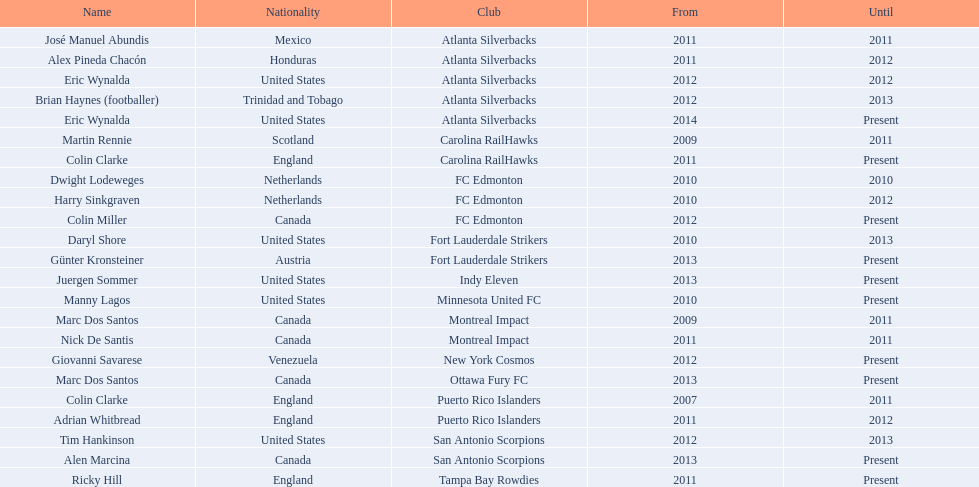What year did marc dos santos start as coach? 2009. Which other starting years correspond with this year? 2009. Who was the other coach with this starting year Martin Rennie. 